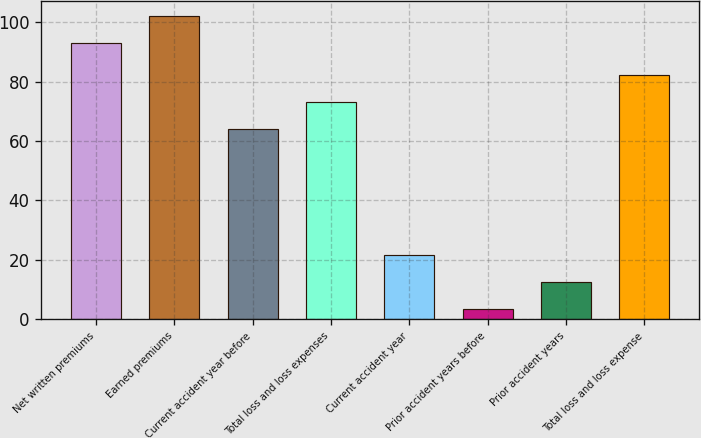<chart> <loc_0><loc_0><loc_500><loc_500><bar_chart><fcel>Net written premiums<fcel>Earned premiums<fcel>Current accident year before<fcel>Total loss and loss expenses<fcel>Current accident year<fcel>Prior accident years before<fcel>Prior accident years<fcel>Total loss and loss expense<nl><fcel>93<fcel>102.16<fcel>64<fcel>73.16<fcel>21.72<fcel>3.4<fcel>12.56<fcel>82.32<nl></chart> 